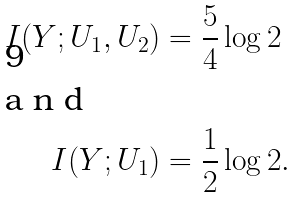Convert formula to latex. <formula><loc_0><loc_0><loc_500><loc_500>I ( Y ; U _ { 1 } , U _ { 2 } ) & = \frac { 5 } { 4 } \log 2 \\ \intertext { a n d } I ( Y ; U _ { 1 } ) & = \frac { 1 } { 2 } \log 2 .</formula> 